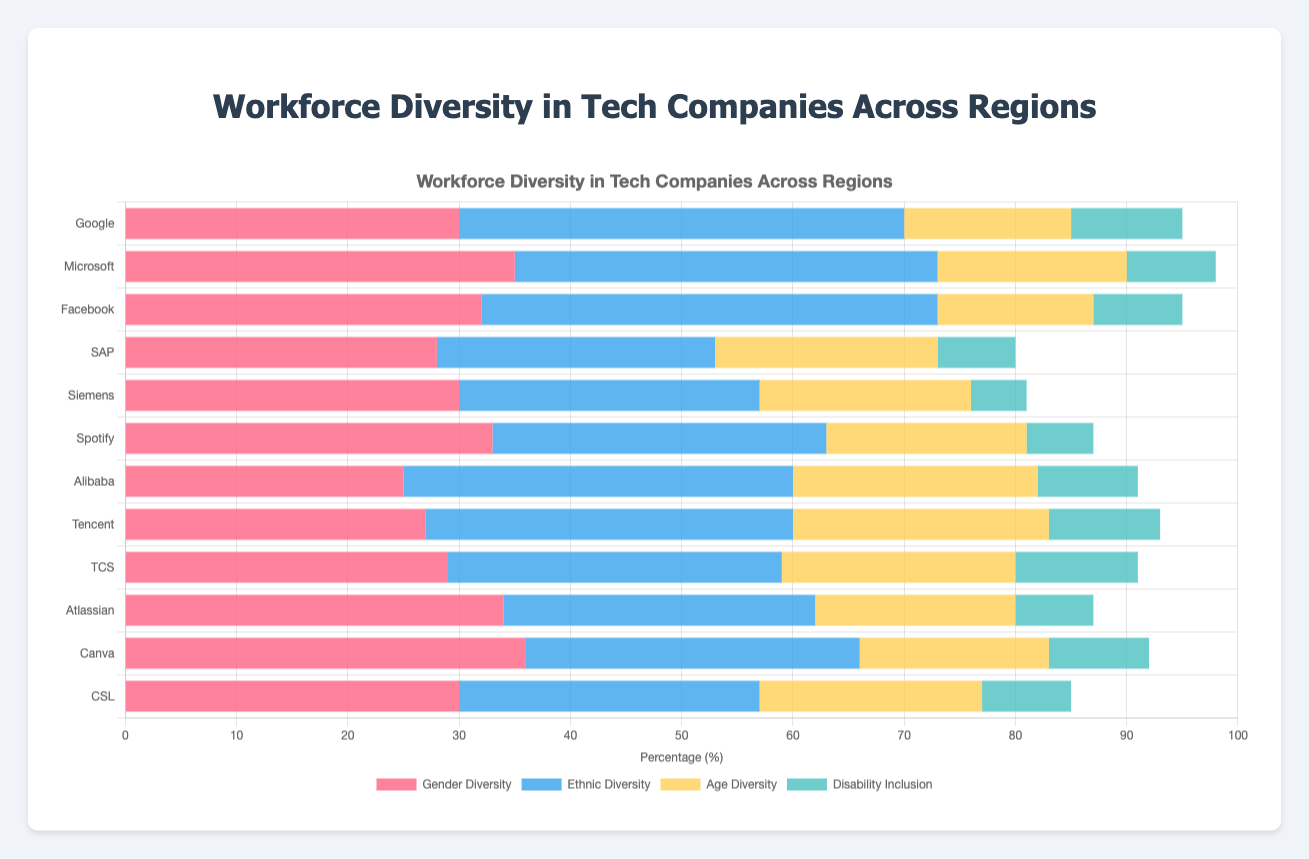Which company in North America has the highest gender diversity? The bar for gender diversity is tallest for Microsoft among North American companies.
Answer: Microsoft How does Alibaba's disability inclusion compare to Atlassian's disability inclusion? The height of the bar representing disability inclusion for Alibaba is higher than Atlassian, indicating Alibaba has a higher percentage.
Answer: Alibaba is higher Which region generally has the highest ethnic diversity across different companies? By comparing the overall lengths of the bars for ethnic diversity across regions, North America's bars appear the longest overall, indicating the highest ethnic diversity.
Answer: North America What is the average age diversity for companies in Europe? Summing the age diversity percentages for SAP (20), Siemens (19), and Spotify (18) gives a total of 57. Dividing this by 3 (the number of companies) gives the average age diversity.
Answer: 19 Compare the gender diversity of the company with the lowest value and the one with the highest value. Simplifying this comparison, the company Canva has the highest gender diversity (36%), whereas Alibaba has the lowest (25%). Thus, Canva’s value is higher by 11%.
Answer: Canva - Alibaba +11% How does the ethnic diversity of Facebook compare to Tencent? The bar for ethnic diversity for Facebook shows 41%, which is higher compared to Tencent's 33%.
Answer: Facebook is higher Which company has the least disability inclusion in Europe, and what is its value? By observing the bars in Europe, Siemens has the shortest bar for disability inclusion, indicating the lowest value, which is 5%.
Answer: Siemens, 5% Based on the chart, which company in Australia has the highest age diversity? By analyzing the bars in the age diversity metric, CSL has the tallest bar among Australian companies, indicating the highest age diversity at 20%.
Answer: CSL Calculate the sum of gender diversity percentages for all companies in Asia. Summing up the gender diversity percentages for Alibaba (25), Tencent (27), and TCS (29) gives a total of 81%.
Answer: 81% What is the range of disability inclusion percentages across the companies in North America? The minimum disability inclusion value in North America is 8% (Microsoft and Facebook), and the maximum is 10% (Google). The range is 10 - 8 = 2%.
Answer: 2% 